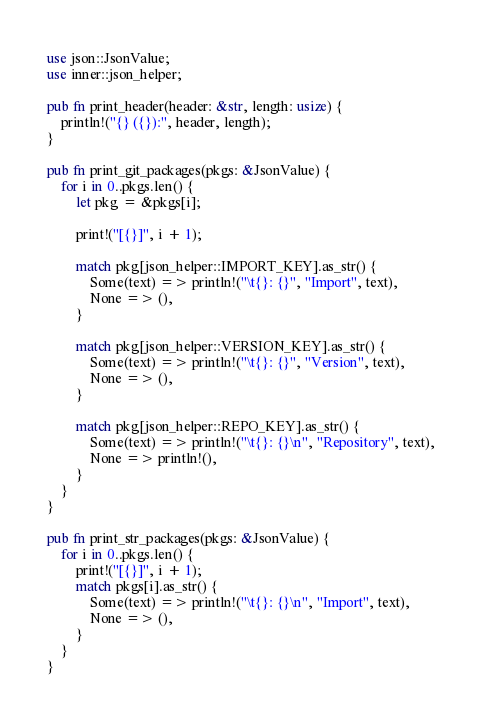<code> <loc_0><loc_0><loc_500><loc_500><_Rust_>use json::JsonValue;
use inner::json_helper;

pub fn print_header(header: &str, length: usize) {
    println!("{} ({}):", header, length);
}

pub fn print_git_packages(pkgs: &JsonValue) {
    for i in 0..pkgs.len() {
        let pkg = &pkgs[i];

        print!("[{}]", i + 1);

        match pkg[json_helper::IMPORT_KEY].as_str() {
            Some(text) => println!("\t{}: {}", "Import", text),
            None => (),
        }

        match pkg[json_helper::VERSION_KEY].as_str() {
            Some(text) => println!("\t{}: {}", "Version", text),
            None => (),
        }

        match pkg[json_helper::REPO_KEY].as_str() {
            Some(text) => println!("\t{}: {}\n", "Repository", text),
            None => println!(),
        }
    }
}

pub fn print_str_packages(pkgs: &JsonValue) {
    for i in 0..pkgs.len() {
        print!("[{}]", i + 1);
        match pkgs[i].as_str() {
            Some(text) => println!("\t{}: {}\n", "Import", text),
            None => (),
        }
    }
}
</code> 